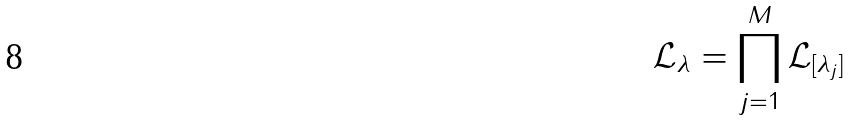Convert formula to latex. <formula><loc_0><loc_0><loc_500><loc_500>\mathcal { L } _ { \lambda } = \prod _ { j = 1 } ^ { M } \mathcal { L } _ { [ \lambda _ { j } ] }</formula> 